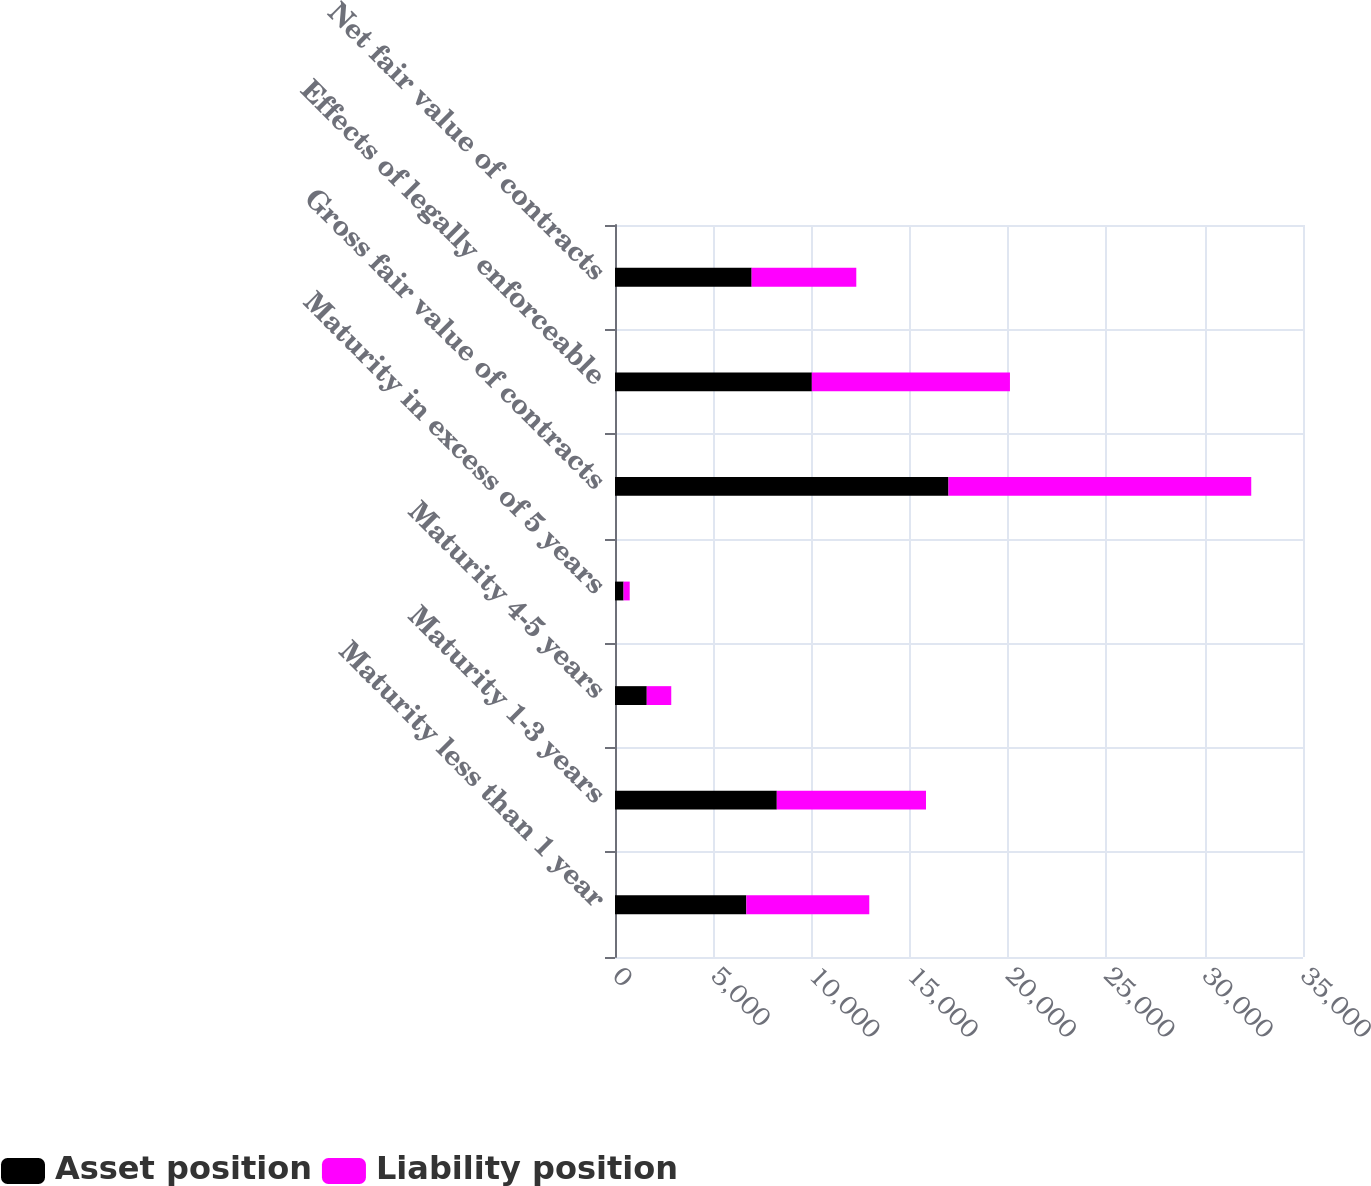Convert chart to OTSL. <chart><loc_0><loc_0><loc_500><loc_500><stacked_bar_chart><ecel><fcel>Maturity less than 1 year<fcel>Maturity 1-3 years<fcel>Maturity 4-5 years<fcel>Maturity in excess of 5 years<fcel>Gross fair value of contracts<fcel>Effects of legally enforceable<fcel>Net fair value of contracts<nl><fcel>Asset position<fcel>6682<fcel>8231<fcel>1616<fcel>436<fcel>16965<fcel>10014<fcel>6951<nl><fcel>Liability position<fcel>6254<fcel>7590<fcel>1246<fcel>312<fcel>15402<fcel>10078<fcel>5324<nl></chart> 